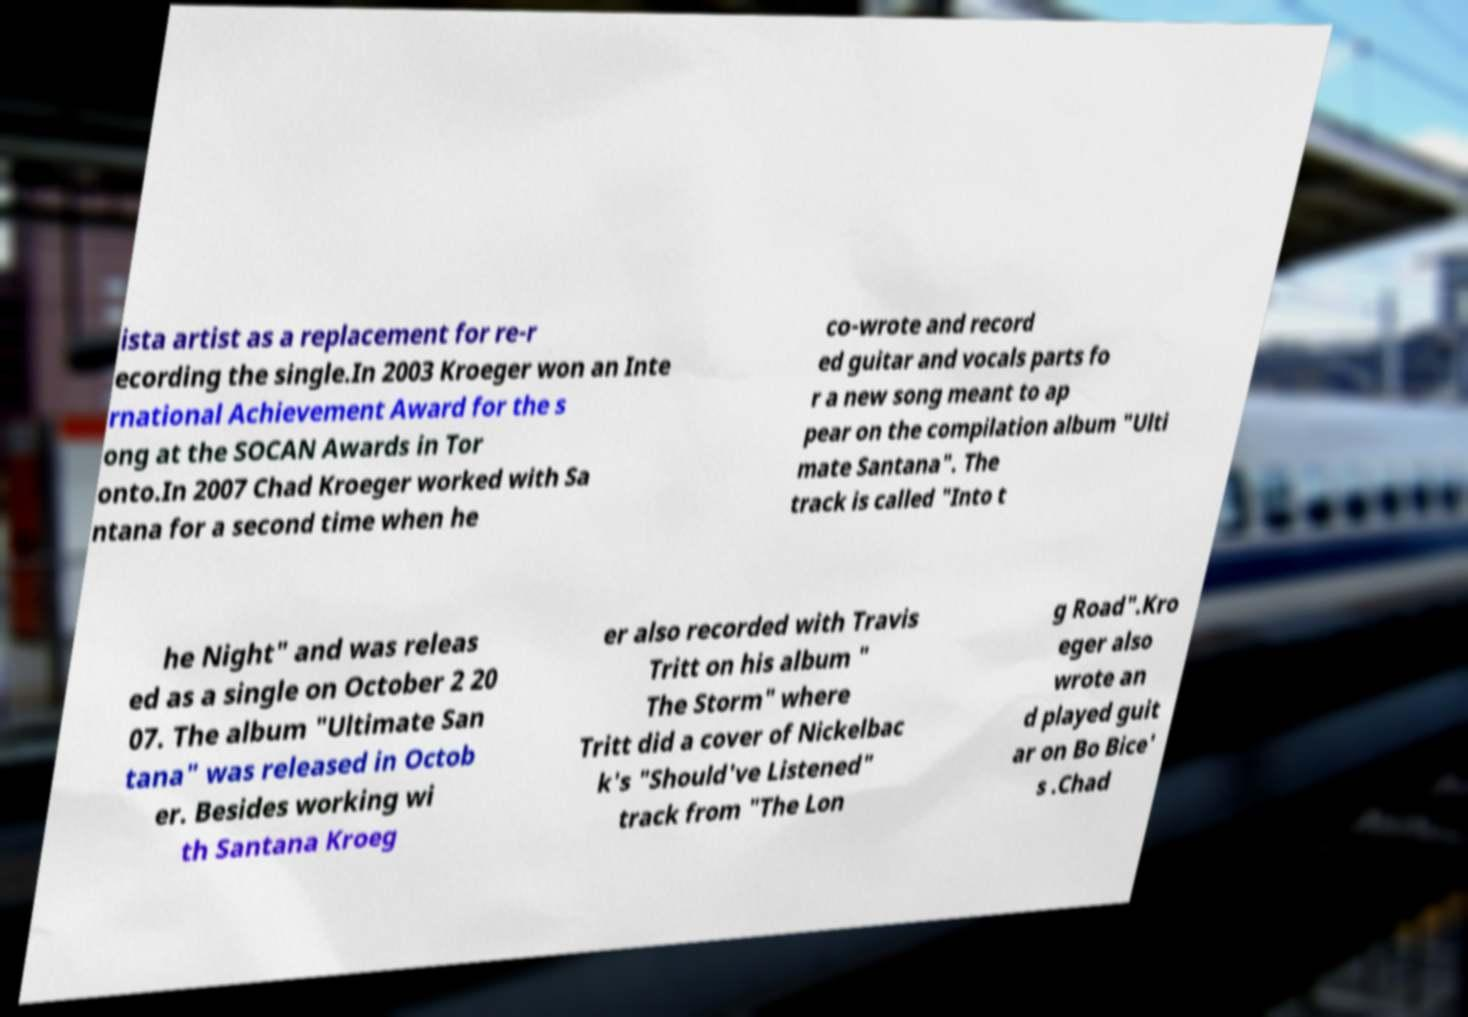There's text embedded in this image that I need extracted. Can you transcribe it verbatim? ista artist as a replacement for re-r ecording the single.In 2003 Kroeger won an Inte rnational Achievement Award for the s ong at the SOCAN Awards in Tor onto.In 2007 Chad Kroeger worked with Sa ntana for a second time when he co-wrote and record ed guitar and vocals parts fo r a new song meant to ap pear on the compilation album "Ulti mate Santana". The track is called "Into t he Night" and was releas ed as a single on October 2 20 07. The album "Ultimate San tana" was released in Octob er. Besides working wi th Santana Kroeg er also recorded with Travis Tritt on his album " The Storm" where Tritt did a cover of Nickelbac k's "Should've Listened" track from "The Lon g Road".Kro eger also wrote an d played guit ar on Bo Bice' s .Chad 